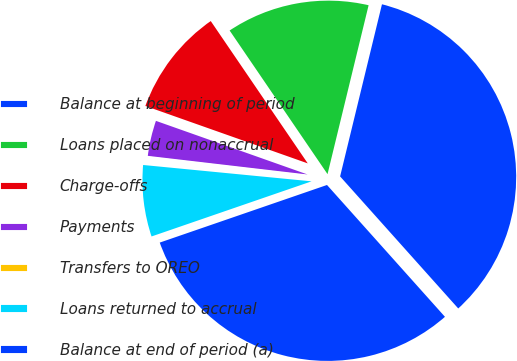<chart> <loc_0><loc_0><loc_500><loc_500><pie_chart><fcel>Balance at beginning of period<fcel>Loans placed on nonaccrual<fcel>Charge-offs<fcel>Payments<fcel>Transfers to OREO<fcel>Loans returned to accrual<fcel>Balance at end of period (a)<nl><fcel>34.59%<fcel>13.32%<fcel>10.07%<fcel>3.56%<fcel>0.31%<fcel>6.82%<fcel>31.34%<nl></chart> 